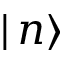Convert formula to latex. <formula><loc_0><loc_0><loc_500><loc_500>| \, n \rangle</formula> 